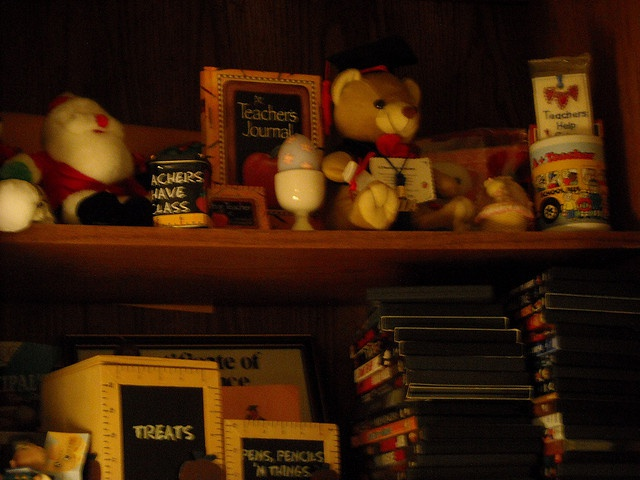Describe the objects in this image and their specific colors. I can see teddy bear in black, olive, and maroon tones, teddy bear in black, maroon, and olive tones, cup in black, maroon, and olive tones, book in black, maroon, and olive tones, and book in black, maroon, and brown tones in this image. 